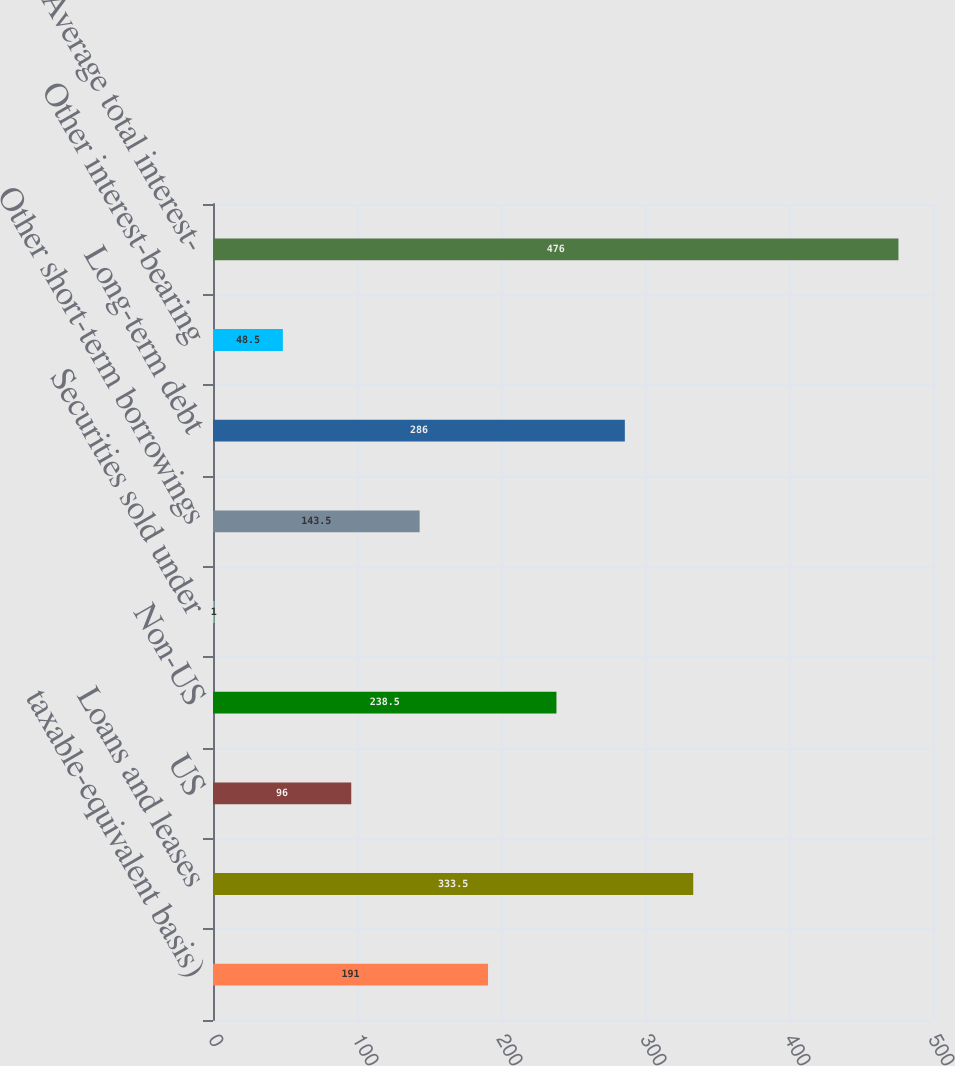<chart> <loc_0><loc_0><loc_500><loc_500><bar_chart><fcel>taxable-equivalent basis)<fcel>Loans and leases<fcel>US<fcel>Non-US<fcel>Securities sold under<fcel>Other short-term borrowings<fcel>Long-term debt<fcel>Other interest-bearing<fcel>Average total interest-<nl><fcel>191<fcel>333.5<fcel>96<fcel>238.5<fcel>1<fcel>143.5<fcel>286<fcel>48.5<fcel>476<nl></chart> 